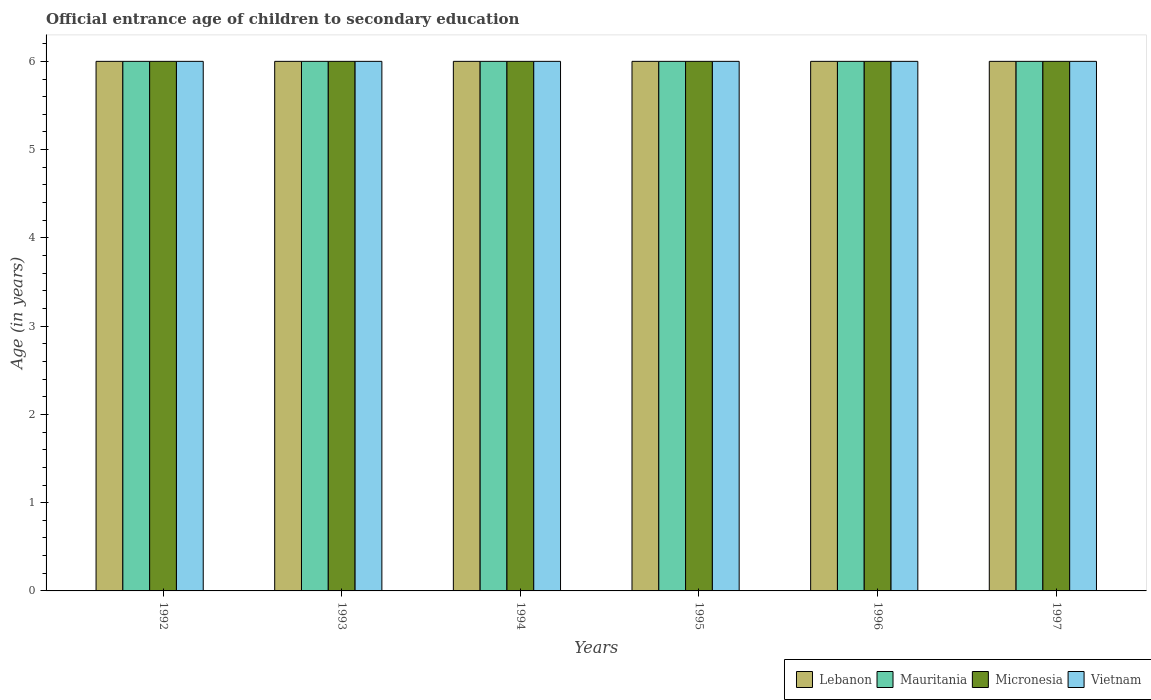How many different coloured bars are there?
Your answer should be compact. 4. Are the number of bars on each tick of the X-axis equal?
Provide a short and direct response. Yes. How many bars are there on the 3rd tick from the left?
Give a very brief answer. 4. How many bars are there on the 2nd tick from the right?
Ensure brevity in your answer.  4. What is the label of the 4th group of bars from the left?
Offer a very short reply. 1995. In how many cases, is the number of bars for a given year not equal to the number of legend labels?
Give a very brief answer. 0. Across all years, what is the maximum secondary school starting age of children in Micronesia?
Provide a succinct answer. 6. In which year was the secondary school starting age of children in Micronesia minimum?
Your answer should be very brief. 1992. What is the total secondary school starting age of children in Lebanon in the graph?
Your response must be concise. 36. Is the difference between the secondary school starting age of children in Vietnam in 1993 and 1997 greater than the difference between the secondary school starting age of children in Lebanon in 1993 and 1997?
Offer a very short reply. No. What is the difference between the highest and the second highest secondary school starting age of children in Lebanon?
Provide a succinct answer. 0. In how many years, is the secondary school starting age of children in Vietnam greater than the average secondary school starting age of children in Vietnam taken over all years?
Provide a short and direct response. 0. What does the 2nd bar from the left in 1996 represents?
Your answer should be very brief. Mauritania. What does the 1st bar from the right in 1993 represents?
Your response must be concise. Vietnam. Is it the case that in every year, the sum of the secondary school starting age of children in Mauritania and secondary school starting age of children in Micronesia is greater than the secondary school starting age of children in Vietnam?
Provide a short and direct response. Yes. Are all the bars in the graph horizontal?
Offer a very short reply. No. What is the difference between two consecutive major ticks on the Y-axis?
Offer a very short reply. 1. Does the graph contain any zero values?
Keep it short and to the point. No. Does the graph contain grids?
Your answer should be very brief. No. Where does the legend appear in the graph?
Your response must be concise. Bottom right. How many legend labels are there?
Your answer should be compact. 4. How are the legend labels stacked?
Give a very brief answer. Horizontal. What is the title of the graph?
Provide a succinct answer. Official entrance age of children to secondary education. Does "New Zealand" appear as one of the legend labels in the graph?
Ensure brevity in your answer.  No. What is the label or title of the X-axis?
Your answer should be very brief. Years. What is the label or title of the Y-axis?
Make the answer very short. Age (in years). What is the Age (in years) in Lebanon in 1992?
Provide a succinct answer. 6. What is the Age (in years) of Vietnam in 1992?
Your response must be concise. 6. What is the Age (in years) in Vietnam in 1994?
Offer a very short reply. 6. What is the Age (in years) of Lebanon in 1995?
Your answer should be very brief. 6. What is the Age (in years) of Micronesia in 1995?
Offer a terse response. 6. What is the Age (in years) of Lebanon in 1996?
Give a very brief answer. 6. What is the Age (in years) of Vietnam in 1996?
Provide a succinct answer. 6. What is the Age (in years) in Micronesia in 1997?
Ensure brevity in your answer.  6. What is the Age (in years) of Vietnam in 1997?
Your answer should be very brief. 6. Across all years, what is the maximum Age (in years) of Lebanon?
Provide a short and direct response. 6. Across all years, what is the maximum Age (in years) in Vietnam?
Provide a succinct answer. 6. Across all years, what is the minimum Age (in years) of Lebanon?
Give a very brief answer. 6. Across all years, what is the minimum Age (in years) of Mauritania?
Keep it short and to the point. 6. Across all years, what is the minimum Age (in years) of Micronesia?
Offer a very short reply. 6. What is the total Age (in years) in Mauritania in the graph?
Provide a short and direct response. 36. What is the total Age (in years) in Vietnam in the graph?
Your answer should be compact. 36. What is the difference between the Age (in years) of Lebanon in 1992 and that in 1993?
Your answer should be compact. 0. What is the difference between the Age (in years) of Mauritania in 1992 and that in 1993?
Your answer should be very brief. 0. What is the difference between the Age (in years) of Micronesia in 1992 and that in 1994?
Your answer should be compact. 0. What is the difference between the Age (in years) of Vietnam in 1992 and that in 1994?
Your answer should be very brief. 0. What is the difference between the Age (in years) in Micronesia in 1992 and that in 1995?
Keep it short and to the point. 0. What is the difference between the Age (in years) of Vietnam in 1992 and that in 1995?
Give a very brief answer. 0. What is the difference between the Age (in years) in Mauritania in 1992 and that in 1996?
Offer a very short reply. 0. What is the difference between the Age (in years) in Micronesia in 1992 and that in 1996?
Provide a succinct answer. 0. What is the difference between the Age (in years) in Vietnam in 1992 and that in 1996?
Offer a terse response. 0. What is the difference between the Age (in years) in Lebanon in 1992 and that in 1997?
Ensure brevity in your answer.  0. What is the difference between the Age (in years) in Vietnam in 1992 and that in 1997?
Ensure brevity in your answer.  0. What is the difference between the Age (in years) in Lebanon in 1993 and that in 1994?
Make the answer very short. 0. What is the difference between the Age (in years) of Mauritania in 1993 and that in 1994?
Provide a succinct answer. 0. What is the difference between the Age (in years) in Vietnam in 1993 and that in 1994?
Your answer should be very brief. 0. What is the difference between the Age (in years) of Lebanon in 1993 and that in 1995?
Ensure brevity in your answer.  0. What is the difference between the Age (in years) of Mauritania in 1993 and that in 1995?
Offer a terse response. 0. What is the difference between the Age (in years) of Micronesia in 1993 and that in 1995?
Provide a short and direct response. 0. What is the difference between the Age (in years) in Vietnam in 1993 and that in 1995?
Your answer should be very brief. 0. What is the difference between the Age (in years) in Mauritania in 1993 and that in 1996?
Offer a very short reply. 0. What is the difference between the Age (in years) in Mauritania in 1993 and that in 1997?
Ensure brevity in your answer.  0. What is the difference between the Age (in years) in Lebanon in 1994 and that in 1995?
Give a very brief answer. 0. What is the difference between the Age (in years) of Mauritania in 1994 and that in 1995?
Provide a succinct answer. 0. What is the difference between the Age (in years) of Vietnam in 1994 and that in 1995?
Provide a succinct answer. 0. What is the difference between the Age (in years) in Lebanon in 1994 and that in 1996?
Offer a very short reply. 0. What is the difference between the Age (in years) in Micronesia in 1994 and that in 1996?
Your response must be concise. 0. What is the difference between the Age (in years) in Vietnam in 1994 and that in 1997?
Offer a very short reply. 0. What is the difference between the Age (in years) in Micronesia in 1995 and that in 1996?
Give a very brief answer. 0. What is the difference between the Age (in years) in Vietnam in 1995 and that in 1996?
Keep it short and to the point. 0. What is the difference between the Age (in years) of Mauritania in 1995 and that in 1997?
Offer a very short reply. 0. What is the difference between the Age (in years) of Vietnam in 1995 and that in 1997?
Provide a succinct answer. 0. What is the difference between the Age (in years) of Lebanon in 1996 and that in 1997?
Give a very brief answer. 0. What is the difference between the Age (in years) in Mauritania in 1996 and that in 1997?
Your response must be concise. 0. What is the difference between the Age (in years) of Lebanon in 1992 and the Age (in years) of Mauritania in 1993?
Your answer should be compact. 0. What is the difference between the Age (in years) in Micronesia in 1992 and the Age (in years) in Vietnam in 1993?
Provide a short and direct response. 0. What is the difference between the Age (in years) of Lebanon in 1992 and the Age (in years) of Mauritania in 1994?
Provide a succinct answer. 0. What is the difference between the Age (in years) of Lebanon in 1992 and the Age (in years) of Micronesia in 1994?
Ensure brevity in your answer.  0. What is the difference between the Age (in years) in Lebanon in 1992 and the Age (in years) in Vietnam in 1994?
Make the answer very short. 0. What is the difference between the Age (in years) in Mauritania in 1992 and the Age (in years) in Micronesia in 1994?
Your response must be concise. 0. What is the difference between the Age (in years) of Mauritania in 1992 and the Age (in years) of Vietnam in 1994?
Ensure brevity in your answer.  0. What is the difference between the Age (in years) of Micronesia in 1992 and the Age (in years) of Vietnam in 1994?
Offer a terse response. 0. What is the difference between the Age (in years) in Lebanon in 1992 and the Age (in years) in Mauritania in 1995?
Provide a short and direct response. 0. What is the difference between the Age (in years) of Lebanon in 1992 and the Age (in years) of Micronesia in 1995?
Offer a terse response. 0. What is the difference between the Age (in years) in Lebanon in 1992 and the Age (in years) in Vietnam in 1995?
Ensure brevity in your answer.  0. What is the difference between the Age (in years) in Mauritania in 1992 and the Age (in years) in Micronesia in 1995?
Keep it short and to the point. 0. What is the difference between the Age (in years) of Lebanon in 1992 and the Age (in years) of Mauritania in 1996?
Offer a very short reply. 0. What is the difference between the Age (in years) in Lebanon in 1992 and the Age (in years) in Micronesia in 1996?
Provide a succinct answer. 0. What is the difference between the Age (in years) of Micronesia in 1992 and the Age (in years) of Vietnam in 1996?
Your response must be concise. 0. What is the difference between the Age (in years) in Mauritania in 1992 and the Age (in years) in Micronesia in 1997?
Give a very brief answer. 0. What is the difference between the Age (in years) in Mauritania in 1993 and the Age (in years) in Vietnam in 1994?
Make the answer very short. 0. What is the difference between the Age (in years) in Lebanon in 1993 and the Age (in years) in Mauritania in 1995?
Your response must be concise. 0. What is the difference between the Age (in years) in Mauritania in 1993 and the Age (in years) in Micronesia in 1995?
Your answer should be very brief. 0. What is the difference between the Age (in years) in Mauritania in 1993 and the Age (in years) in Vietnam in 1995?
Offer a terse response. 0. What is the difference between the Age (in years) in Lebanon in 1993 and the Age (in years) in Mauritania in 1996?
Offer a very short reply. 0. What is the difference between the Age (in years) of Lebanon in 1993 and the Age (in years) of Vietnam in 1996?
Ensure brevity in your answer.  0. What is the difference between the Age (in years) in Lebanon in 1993 and the Age (in years) in Mauritania in 1997?
Give a very brief answer. 0. What is the difference between the Age (in years) in Lebanon in 1993 and the Age (in years) in Micronesia in 1997?
Your answer should be very brief. 0. What is the difference between the Age (in years) in Mauritania in 1993 and the Age (in years) in Vietnam in 1997?
Your response must be concise. 0. What is the difference between the Age (in years) in Micronesia in 1993 and the Age (in years) in Vietnam in 1997?
Offer a terse response. 0. What is the difference between the Age (in years) in Lebanon in 1994 and the Age (in years) in Mauritania in 1995?
Offer a very short reply. 0. What is the difference between the Age (in years) in Mauritania in 1994 and the Age (in years) in Micronesia in 1995?
Provide a succinct answer. 0. What is the difference between the Age (in years) in Lebanon in 1994 and the Age (in years) in Micronesia in 1996?
Ensure brevity in your answer.  0. What is the difference between the Age (in years) in Lebanon in 1994 and the Age (in years) in Vietnam in 1996?
Your response must be concise. 0. What is the difference between the Age (in years) in Mauritania in 1994 and the Age (in years) in Vietnam in 1996?
Offer a very short reply. 0. What is the difference between the Age (in years) in Micronesia in 1994 and the Age (in years) in Vietnam in 1996?
Your response must be concise. 0. What is the difference between the Age (in years) of Lebanon in 1994 and the Age (in years) of Mauritania in 1997?
Ensure brevity in your answer.  0. What is the difference between the Age (in years) of Lebanon in 1994 and the Age (in years) of Micronesia in 1997?
Ensure brevity in your answer.  0. What is the difference between the Age (in years) of Lebanon in 1994 and the Age (in years) of Vietnam in 1997?
Your response must be concise. 0. What is the difference between the Age (in years) in Mauritania in 1994 and the Age (in years) in Micronesia in 1997?
Make the answer very short. 0. What is the difference between the Age (in years) of Micronesia in 1994 and the Age (in years) of Vietnam in 1997?
Offer a terse response. 0. What is the difference between the Age (in years) in Lebanon in 1995 and the Age (in years) in Micronesia in 1996?
Make the answer very short. 0. What is the difference between the Age (in years) in Lebanon in 1995 and the Age (in years) in Vietnam in 1996?
Provide a succinct answer. 0. What is the difference between the Age (in years) of Mauritania in 1995 and the Age (in years) of Micronesia in 1996?
Ensure brevity in your answer.  0. What is the difference between the Age (in years) of Lebanon in 1995 and the Age (in years) of Micronesia in 1997?
Give a very brief answer. 0. What is the difference between the Age (in years) of Mauritania in 1995 and the Age (in years) of Vietnam in 1997?
Your answer should be compact. 0. What is the difference between the Age (in years) in Lebanon in 1996 and the Age (in years) in Mauritania in 1997?
Make the answer very short. 0. What is the difference between the Age (in years) of Mauritania in 1996 and the Age (in years) of Micronesia in 1997?
Ensure brevity in your answer.  0. What is the difference between the Age (in years) in Mauritania in 1996 and the Age (in years) in Vietnam in 1997?
Make the answer very short. 0. What is the average Age (in years) in Mauritania per year?
Ensure brevity in your answer.  6. What is the average Age (in years) of Micronesia per year?
Provide a succinct answer. 6. What is the average Age (in years) of Vietnam per year?
Make the answer very short. 6. In the year 1992, what is the difference between the Age (in years) of Lebanon and Age (in years) of Micronesia?
Provide a short and direct response. 0. In the year 1992, what is the difference between the Age (in years) in Lebanon and Age (in years) in Vietnam?
Keep it short and to the point. 0. In the year 1992, what is the difference between the Age (in years) in Mauritania and Age (in years) in Micronesia?
Provide a succinct answer. 0. In the year 1993, what is the difference between the Age (in years) of Lebanon and Age (in years) of Mauritania?
Give a very brief answer. 0. In the year 1993, what is the difference between the Age (in years) in Lebanon and Age (in years) in Vietnam?
Offer a very short reply. 0. In the year 1993, what is the difference between the Age (in years) of Mauritania and Age (in years) of Micronesia?
Provide a succinct answer. 0. In the year 1993, what is the difference between the Age (in years) of Mauritania and Age (in years) of Vietnam?
Give a very brief answer. 0. In the year 1994, what is the difference between the Age (in years) of Lebanon and Age (in years) of Mauritania?
Provide a succinct answer. 0. In the year 1994, what is the difference between the Age (in years) in Lebanon and Age (in years) in Micronesia?
Your response must be concise. 0. In the year 1994, what is the difference between the Age (in years) of Lebanon and Age (in years) of Vietnam?
Make the answer very short. 0. In the year 1994, what is the difference between the Age (in years) of Mauritania and Age (in years) of Vietnam?
Your answer should be very brief. 0. In the year 1995, what is the difference between the Age (in years) of Lebanon and Age (in years) of Micronesia?
Your answer should be very brief. 0. In the year 1995, what is the difference between the Age (in years) of Lebanon and Age (in years) of Vietnam?
Your answer should be very brief. 0. In the year 1995, what is the difference between the Age (in years) in Mauritania and Age (in years) in Micronesia?
Make the answer very short. 0. In the year 1995, what is the difference between the Age (in years) in Mauritania and Age (in years) in Vietnam?
Keep it short and to the point. 0. In the year 1996, what is the difference between the Age (in years) of Lebanon and Age (in years) of Mauritania?
Make the answer very short. 0. In the year 1996, what is the difference between the Age (in years) in Lebanon and Age (in years) in Micronesia?
Keep it short and to the point. 0. In the year 1996, what is the difference between the Age (in years) of Mauritania and Age (in years) of Micronesia?
Keep it short and to the point. 0. In the year 1996, what is the difference between the Age (in years) in Micronesia and Age (in years) in Vietnam?
Offer a very short reply. 0. In the year 1997, what is the difference between the Age (in years) in Lebanon and Age (in years) in Vietnam?
Your answer should be compact. 0. In the year 1997, what is the difference between the Age (in years) of Mauritania and Age (in years) of Micronesia?
Provide a succinct answer. 0. What is the ratio of the Age (in years) in Lebanon in 1992 to that in 1993?
Keep it short and to the point. 1. What is the ratio of the Age (in years) in Mauritania in 1992 to that in 1994?
Make the answer very short. 1. What is the ratio of the Age (in years) of Micronesia in 1992 to that in 1995?
Ensure brevity in your answer.  1. What is the ratio of the Age (in years) of Lebanon in 1992 to that in 1996?
Keep it short and to the point. 1. What is the ratio of the Age (in years) of Mauritania in 1992 to that in 1996?
Ensure brevity in your answer.  1. What is the ratio of the Age (in years) in Mauritania in 1992 to that in 1997?
Provide a succinct answer. 1. What is the ratio of the Age (in years) in Micronesia in 1992 to that in 1997?
Provide a succinct answer. 1. What is the ratio of the Age (in years) of Vietnam in 1992 to that in 1997?
Ensure brevity in your answer.  1. What is the ratio of the Age (in years) of Lebanon in 1993 to that in 1994?
Your response must be concise. 1. What is the ratio of the Age (in years) of Lebanon in 1993 to that in 1995?
Make the answer very short. 1. What is the ratio of the Age (in years) in Mauritania in 1993 to that in 1995?
Provide a short and direct response. 1. What is the ratio of the Age (in years) of Micronesia in 1993 to that in 1996?
Ensure brevity in your answer.  1. What is the ratio of the Age (in years) in Vietnam in 1993 to that in 1996?
Keep it short and to the point. 1. What is the ratio of the Age (in years) of Lebanon in 1993 to that in 1997?
Ensure brevity in your answer.  1. What is the ratio of the Age (in years) in Micronesia in 1993 to that in 1997?
Your answer should be very brief. 1. What is the ratio of the Age (in years) of Micronesia in 1994 to that in 1995?
Your answer should be very brief. 1. What is the ratio of the Age (in years) of Micronesia in 1994 to that in 1996?
Provide a short and direct response. 1. What is the ratio of the Age (in years) of Vietnam in 1994 to that in 1996?
Make the answer very short. 1. What is the ratio of the Age (in years) of Micronesia in 1994 to that in 1997?
Keep it short and to the point. 1. What is the ratio of the Age (in years) of Lebanon in 1995 to that in 1996?
Your answer should be very brief. 1. What is the ratio of the Age (in years) in Vietnam in 1995 to that in 1997?
Provide a succinct answer. 1. What is the ratio of the Age (in years) in Micronesia in 1996 to that in 1997?
Your response must be concise. 1. What is the difference between the highest and the second highest Age (in years) in Lebanon?
Keep it short and to the point. 0. What is the difference between the highest and the second highest Age (in years) in Micronesia?
Your answer should be very brief. 0. What is the difference between the highest and the second highest Age (in years) in Vietnam?
Ensure brevity in your answer.  0. What is the difference between the highest and the lowest Age (in years) in Lebanon?
Provide a short and direct response. 0. What is the difference between the highest and the lowest Age (in years) in Mauritania?
Provide a short and direct response. 0. What is the difference between the highest and the lowest Age (in years) in Micronesia?
Make the answer very short. 0. What is the difference between the highest and the lowest Age (in years) of Vietnam?
Provide a succinct answer. 0. 